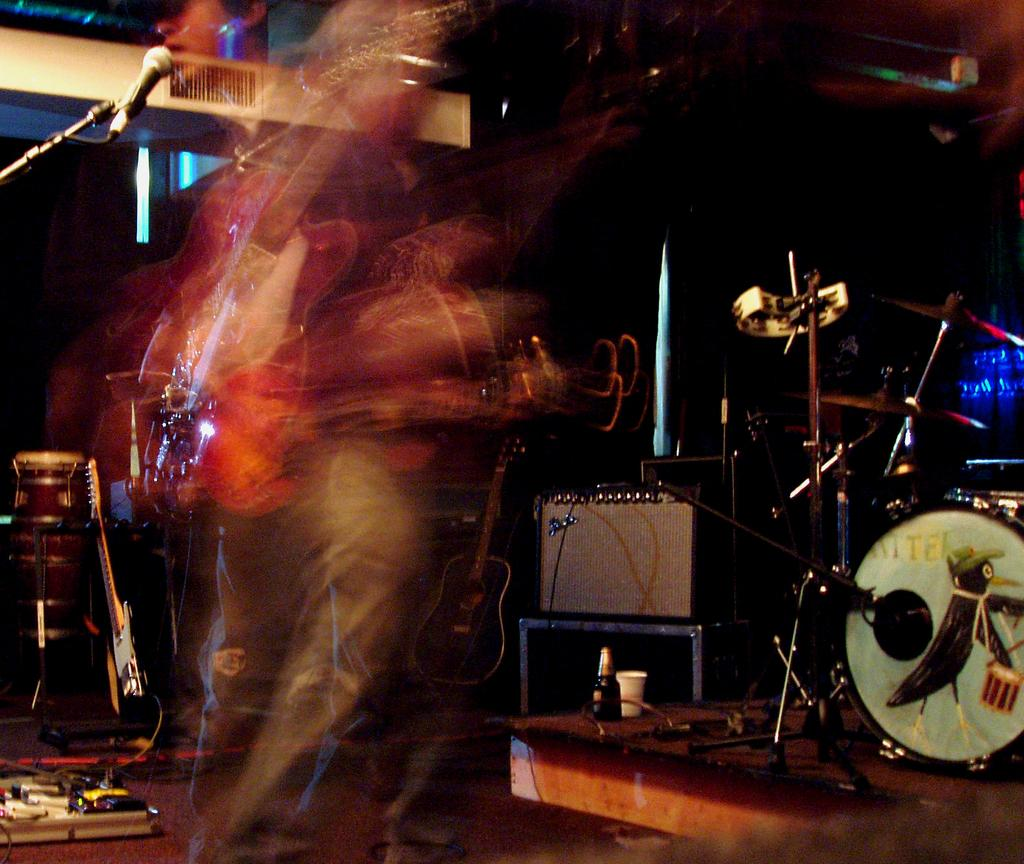What is the main subject of the image? There is a blurred person in the image. What is in front of the person? There is a microphone in front of the person. What other objects can be seen in the image? There is a bottle and a cup in the image. What type of objects are related to music in the image? There are music instruments in the image. What type of hat is the group wearing in the image? There is no group present in the image, and no hats are visible. 